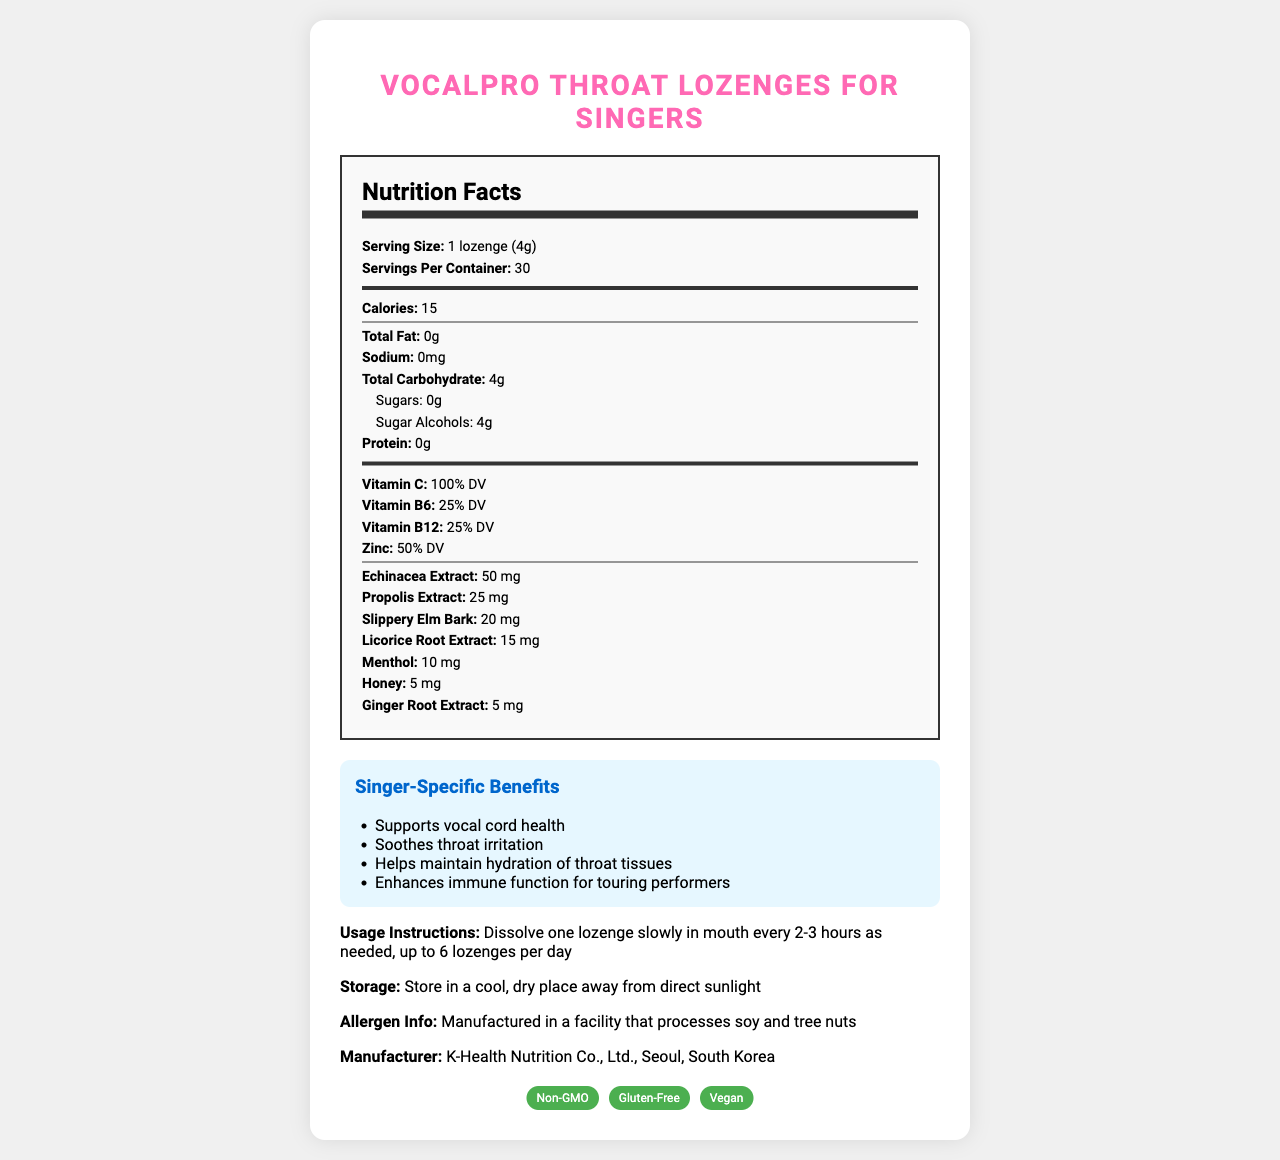what is the serving size of VocalPro Throat Lozenges for Singers? The document specifies the serving size under the Nutrition Facts section as "1 lozenge (4g)".
Answer: 1 lozenge (4g) how many calories are in one lozenge? The document lists "Calories" as 15 under the Nutrition Facts section.
Answer: 15 how much Vitamin C is in each lozenge? Under the Nutrition Facts, Vitamin C content is marked as "100% DV".
Answer: 100% DV what are some of the singer-specific benefits mentioned? These benefits are highlighted in a special section titled "Singer-Specific Benefits".
Answer: Supports vocal cord health, Soothes throat irritation, Helps maintain hydration of throat tissues, Enhances immune function for touring performers how many servings are there per container? The serving size information in the document indicates there are "servings per container: 30".
Answer: 30 which ingredient is highest in quantity? A. Propolis Extract B. Menthol C. Echinacea Extract D. Slippery Elm Bark Echinacea Extract is listed as 50 mg, the highest among the specific ingredients listed.
Answer: C. Echinacea Extract what is the sugar content of each lozenge? The document specifies "Sugars: 0g" under the Total Carbohydrate category.
Answer: 0 grams are the lozenges gluten-free? The certifications section lists "Gluten-Free" as one of its features.
Answer: Yes are the lozenges safe for someone with a tree nut allergy? The allergen information states that it is manufactured in a facility that processes tree nuts.
Answer: No how often can a lozenge be taken? The usage instructions state to dissolve one lozenge slowly in the mouth every 2-3 hours as needed, up to 6 lozenges per day.
Answer: Every 2-3 hours, up to 6 lozenges per day how much propolis extract is in each lozenge? The specific ingredients list shows "Propolis Extract: 25 mg".
Answer: 25 mg name any two vitamins included in the lozenges and their respective daily values Both vitamins and their daily values are listed under the Vitamins section in the Nutrition Facts.
Answer: Vitamin C: 100% DV, Vitamin B6: 25% DV who manufactures VocalPro Throat Lozenges for Singers? The manufacturer information at the bottom of the document indicates K-Health Nutrition Co., Ltd., Seoul, South Korea.
Answer: K-Health Nutrition Co., Ltd., Seoul, South Korea how should the lozenges be stored? A. In a refrigerator B. At room temperature C. In a cool, dry place D. In a humid area The storage instructions specify storing in a cool, dry place away from direct sunlight.
Answer: C. In a cool, dry place summarize the purpose and key features of VocalPro Throat Lozenges for Singers. The document overall focuses on presenting the nutritional information, benefits, usage instructions, and certifications of the VocalPro Throat Lozenges tailored specifically for singers.
Answer: The purpose of VocalPro Throat Lozenges for Singers is to support vocal health, soothe throat irritation, and enhance immune function with additional benefits tailored for singers. It contains vitamins, herbal extracts, is non-GMO, gluten-free, and vegan. It is manufactured by K-Health Nutrition Co., Ltd., in Seoul, South Korea. Usage instructions suggest consuming one lozenge every 2-3 hours, up to six times a day, and they should be stored in a cool, dry place. what is the main flavor of the lozenges? The specific flavor is not detailed; it only mentions "Natural and artificial flavors."
Answer: Not enough information 